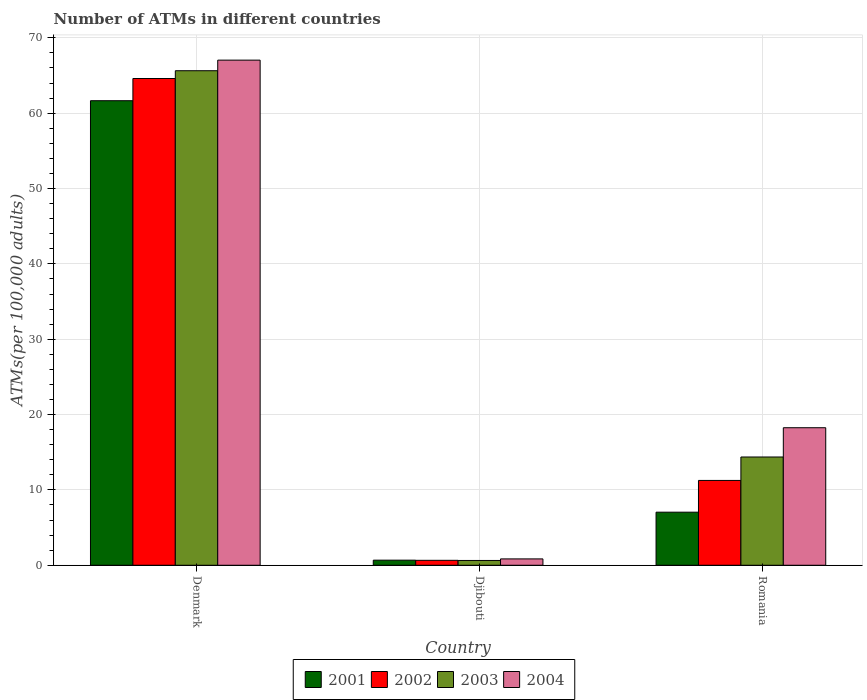How many different coloured bars are there?
Provide a short and direct response. 4. How many groups of bars are there?
Offer a terse response. 3. Are the number of bars per tick equal to the number of legend labels?
Keep it short and to the point. Yes. What is the label of the 3rd group of bars from the left?
Give a very brief answer. Romania. In how many cases, is the number of bars for a given country not equal to the number of legend labels?
Offer a very short reply. 0. What is the number of ATMs in 2003 in Djibouti?
Keep it short and to the point. 0.64. Across all countries, what is the maximum number of ATMs in 2003?
Offer a very short reply. 65.64. Across all countries, what is the minimum number of ATMs in 2003?
Your response must be concise. 0.64. In which country was the number of ATMs in 2001 maximum?
Make the answer very short. Denmark. In which country was the number of ATMs in 2001 minimum?
Make the answer very short. Djibouti. What is the total number of ATMs in 2003 in the graph?
Give a very brief answer. 80.65. What is the difference between the number of ATMs in 2004 in Denmark and that in Djibouti?
Provide a succinct answer. 66.2. What is the difference between the number of ATMs in 2002 in Romania and the number of ATMs in 2001 in Denmark?
Make the answer very short. -50.4. What is the average number of ATMs in 2001 per country?
Provide a succinct answer. 23.13. What is the difference between the number of ATMs of/in 2003 and number of ATMs of/in 2002 in Romania?
Provide a short and direct response. 3.11. What is the ratio of the number of ATMs in 2003 in Denmark to that in Romania?
Provide a short and direct response. 4.57. Is the difference between the number of ATMs in 2003 in Djibouti and Romania greater than the difference between the number of ATMs in 2002 in Djibouti and Romania?
Provide a succinct answer. No. What is the difference between the highest and the second highest number of ATMs in 2001?
Your response must be concise. -60.98. What is the difference between the highest and the lowest number of ATMs in 2003?
Make the answer very short. 65. In how many countries, is the number of ATMs in 2001 greater than the average number of ATMs in 2001 taken over all countries?
Make the answer very short. 1. Is the sum of the number of ATMs in 2004 in Denmark and Romania greater than the maximum number of ATMs in 2001 across all countries?
Your answer should be very brief. Yes. Is it the case that in every country, the sum of the number of ATMs in 2002 and number of ATMs in 2001 is greater than the sum of number of ATMs in 2003 and number of ATMs in 2004?
Offer a terse response. No. What does the 3rd bar from the right in Denmark represents?
Give a very brief answer. 2002. Is it the case that in every country, the sum of the number of ATMs in 2003 and number of ATMs in 2002 is greater than the number of ATMs in 2001?
Make the answer very short. Yes. How many countries are there in the graph?
Your answer should be compact. 3. What is the difference between two consecutive major ticks on the Y-axis?
Your response must be concise. 10. Does the graph contain any zero values?
Provide a short and direct response. No. Where does the legend appear in the graph?
Your response must be concise. Bottom center. How many legend labels are there?
Your response must be concise. 4. What is the title of the graph?
Offer a terse response. Number of ATMs in different countries. What is the label or title of the Y-axis?
Your answer should be very brief. ATMs(per 100,0 adults). What is the ATMs(per 100,000 adults) of 2001 in Denmark?
Make the answer very short. 61.66. What is the ATMs(per 100,000 adults) of 2002 in Denmark?
Offer a very short reply. 64.61. What is the ATMs(per 100,000 adults) in 2003 in Denmark?
Give a very brief answer. 65.64. What is the ATMs(per 100,000 adults) in 2004 in Denmark?
Offer a terse response. 67.04. What is the ATMs(per 100,000 adults) in 2001 in Djibouti?
Offer a very short reply. 0.68. What is the ATMs(per 100,000 adults) in 2002 in Djibouti?
Offer a terse response. 0.66. What is the ATMs(per 100,000 adults) in 2003 in Djibouti?
Your answer should be very brief. 0.64. What is the ATMs(per 100,000 adults) in 2004 in Djibouti?
Provide a succinct answer. 0.84. What is the ATMs(per 100,000 adults) of 2001 in Romania?
Your answer should be compact. 7.04. What is the ATMs(per 100,000 adults) in 2002 in Romania?
Your answer should be compact. 11.26. What is the ATMs(per 100,000 adults) in 2003 in Romania?
Provide a short and direct response. 14.37. What is the ATMs(per 100,000 adults) in 2004 in Romania?
Provide a short and direct response. 18.26. Across all countries, what is the maximum ATMs(per 100,000 adults) in 2001?
Your answer should be very brief. 61.66. Across all countries, what is the maximum ATMs(per 100,000 adults) of 2002?
Make the answer very short. 64.61. Across all countries, what is the maximum ATMs(per 100,000 adults) of 2003?
Your response must be concise. 65.64. Across all countries, what is the maximum ATMs(per 100,000 adults) of 2004?
Keep it short and to the point. 67.04. Across all countries, what is the minimum ATMs(per 100,000 adults) in 2001?
Provide a succinct answer. 0.68. Across all countries, what is the minimum ATMs(per 100,000 adults) in 2002?
Keep it short and to the point. 0.66. Across all countries, what is the minimum ATMs(per 100,000 adults) of 2003?
Your answer should be compact. 0.64. Across all countries, what is the minimum ATMs(per 100,000 adults) in 2004?
Ensure brevity in your answer.  0.84. What is the total ATMs(per 100,000 adults) in 2001 in the graph?
Your answer should be very brief. 69.38. What is the total ATMs(per 100,000 adults) of 2002 in the graph?
Give a very brief answer. 76.52. What is the total ATMs(per 100,000 adults) of 2003 in the graph?
Ensure brevity in your answer.  80.65. What is the total ATMs(per 100,000 adults) in 2004 in the graph?
Your response must be concise. 86.14. What is the difference between the ATMs(per 100,000 adults) of 2001 in Denmark and that in Djibouti?
Your answer should be very brief. 60.98. What is the difference between the ATMs(per 100,000 adults) of 2002 in Denmark and that in Djibouti?
Give a very brief answer. 63.95. What is the difference between the ATMs(per 100,000 adults) in 2003 in Denmark and that in Djibouti?
Offer a very short reply. 65. What is the difference between the ATMs(per 100,000 adults) in 2004 in Denmark and that in Djibouti?
Make the answer very short. 66.2. What is the difference between the ATMs(per 100,000 adults) in 2001 in Denmark and that in Romania?
Your answer should be compact. 54.61. What is the difference between the ATMs(per 100,000 adults) of 2002 in Denmark and that in Romania?
Your response must be concise. 53.35. What is the difference between the ATMs(per 100,000 adults) in 2003 in Denmark and that in Romania?
Provide a succinct answer. 51.27. What is the difference between the ATMs(per 100,000 adults) of 2004 in Denmark and that in Romania?
Give a very brief answer. 48.79. What is the difference between the ATMs(per 100,000 adults) in 2001 in Djibouti and that in Romania?
Your response must be concise. -6.37. What is the difference between the ATMs(per 100,000 adults) in 2002 in Djibouti and that in Romania?
Provide a short and direct response. -10.6. What is the difference between the ATMs(per 100,000 adults) of 2003 in Djibouti and that in Romania?
Provide a succinct answer. -13.73. What is the difference between the ATMs(per 100,000 adults) of 2004 in Djibouti and that in Romania?
Ensure brevity in your answer.  -17.41. What is the difference between the ATMs(per 100,000 adults) in 2001 in Denmark and the ATMs(per 100,000 adults) in 2002 in Djibouti?
Your response must be concise. 61. What is the difference between the ATMs(per 100,000 adults) of 2001 in Denmark and the ATMs(per 100,000 adults) of 2003 in Djibouti?
Provide a short and direct response. 61.02. What is the difference between the ATMs(per 100,000 adults) in 2001 in Denmark and the ATMs(per 100,000 adults) in 2004 in Djibouti?
Your answer should be very brief. 60.81. What is the difference between the ATMs(per 100,000 adults) in 2002 in Denmark and the ATMs(per 100,000 adults) in 2003 in Djibouti?
Offer a very short reply. 63.97. What is the difference between the ATMs(per 100,000 adults) of 2002 in Denmark and the ATMs(per 100,000 adults) of 2004 in Djibouti?
Provide a succinct answer. 63.76. What is the difference between the ATMs(per 100,000 adults) in 2003 in Denmark and the ATMs(per 100,000 adults) in 2004 in Djibouti?
Give a very brief answer. 64.79. What is the difference between the ATMs(per 100,000 adults) of 2001 in Denmark and the ATMs(per 100,000 adults) of 2002 in Romania?
Provide a succinct answer. 50.4. What is the difference between the ATMs(per 100,000 adults) in 2001 in Denmark and the ATMs(per 100,000 adults) in 2003 in Romania?
Your answer should be very brief. 47.29. What is the difference between the ATMs(per 100,000 adults) in 2001 in Denmark and the ATMs(per 100,000 adults) in 2004 in Romania?
Ensure brevity in your answer.  43.4. What is the difference between the ATMs(per 100,000 adults) of 2002 in Denmark and the ATMs(per 100,000 adults) of 2003 in Romania?
Make the answer very short. 50.24. What is the difference between the ATMs(per 100,000 adults) of 2002 in Denmark and the ATMs(per 100,000 adults) of 2004 in Romania?
Your answer should be very brief. 46.35. What is the difference between the ATMs(per 100,000 adults) in 2003 in Denmark and the ATMs(per 100,000 adults) in 2004 in Romania?
Provide a short and direct response. 47.38. What is the difference between the ATMs(per 100,000 adults) in 2001 in Djibouti and the ATMs(per 100,000 adults) in 2002 in Romania?
Make the answer very short. -10.58. What is the difference between the ATMs(per 100,000 adults) in 2001 in Djibouti and the ATMs(per 100,000 adults) in 2003 in Romania?
Your answer should be compact. -13.69. What is the difference between the ATMs(per 100,000 adults) of 2001 in Djibouti and the ATMs(per 100,000 adults) of 2004 in Romania?
Offer a very short reply. -17.58. What is the difference between the ATMs(per 100,000 adults) of 2002 in Djibouti and the ATMs(per 100,000 adults) of 2003 in Romania?
Offer a terse response. -13.71. What is the difference between the ATMs(per 100,000 adults) in 2002 in Djibouti and the ATMs(per 100,000 adults) in 2004 in Romania?
Your response must be concise. -17.6. What is the difference between the ATMs(per 100,000 adults) of 2003 in Djibouti and the ATMs(per 100,000 adults) of 2004 in Romania?
Ensure brevity in your answer.  -17.62. What is the average ATMs(per 100,000 adults) of 2001 per country?
Give a very brief answer. 23.13. What is the average ATMs(per 100,000 adults) of 2002 per country?
Your answer should be compact. 25.51. What is the average ATMs(per 100,000 adults) of 2003 per country?
Make the answer very short. 26.88. What is the average ATMs(per 100,000 adults) in 2004 per country?
Your answer should be very brief. 28.71. What is the difference between the ATMs(per 100,000 adults) of 2001 and ATMs(per 100,000 adults) of 2002 in Denmark?
Your answer should be very brief. -2.95. What is the difference between the ATMs(per 100,000 adults) in 2001 and ATMs(per 100,000 adults) in 2003 in Denmark?
Keep it short and to the point. -3.98. What is the difference between the ATMs(per 100,000 adults) in 2001 and ATMs(per 100,000 adults) in 2004 in Denmark?
Your answer should be compact. -5.39. What is the difference between the ATMs(per 100,000 adults) in 2002 and ATMs(per 100,000 adults) in 2003 in Denmark?
Offer a very short reply. -1.03. What is the difference between the ATMs(per 100,000 adults) of 2002 and ATMs(per 100,000 adults) of 2004 in Denmark?
Make the answer very short. -2.44. What is the difference between the ATMs(per 100,000 adults) in 2003 and ATMs(per 100,000 adults) in 2004 in Denmark?
Your response must be concise. -1.41. What is the difference between the ATMs(per 100,000 adults) in 2001 and ATMs(per 100,000 adults) in 2002 in Djibouti?
Provide a short and direct response. 0.02. What is the difference between the ATMs(per 100,000 adults) of 2001 and ATMs(per 100,000 adults) of 2003 in Djibouti?
Keep it short and to the point. 0.04. What is the difference between the ATMs(per 100,000 adults) of 2001 and ATMs(per 100,000 adults) of 2004 in Djibouti?
Your answer should be very brief. -0.17. What is the difference between the ATMs(per 100,000 adults) of 2002 and ATMs(per 100,000 adults) of 2003 in Djibouti?
Keep it short and to the point. 0.02. What is the difference between the ATMs(per 100,000 adults) in 2002 and ATMs(per 100,000 adults) in 2004 in Djibouti?
Your answer should be compact. -0.19. What is the difference between the ATMs(per 100,000 adults) of 2003 and ATMs(per 100,000 adults) of 2004 in Djibouti?
Provide a succinct answer. -0.21. What is the difference between the ATMs(per 100,000 adults) of 2001 and ATMs(per 100,000 adults) of 2002 in Romania?
Make the answer very short. -4.21. What is the difference between the ATMs(per 100,000 adults) of 2001 and ATMs(per 100,000 adults) of 2003 in Romania?
Your answer should be compact. -7.32. What is the difference between the ATMs(per 100,000 adults) in 2001 and ATMs(per 100,000 adults) in 2004 in Romania?
Give a very brief answer. -11.21. What is the difference between the ATMs(per 100,000 adults) in 2002 and ATMs(per 100,000 adults) in 2003 in Romania?
Provide a short and direct response. -3.11. What is the difference between the ATMs(per 100,000 adults) of 2002 and ATMs(per 100,000 adults) of 2004 in Romania?
Provide a succinct answer. -7. What is the difference between the ATMs(per 100,000 adults) in 2003 and ATMs(per 100,000 adults) in 2004 in Romania?
Your answer should be very brief. -3.89. What is the ratio of the ATMs(per 100,000 adults) of 2001 in Denmark to that in Djibouti?
Give a very brief answer. 91.18. What is the ratio of the ATMs(per 100,000 adults) in 2002 in Denmark to that in Djibouti?
Give a very brief answer. 98.45. What is the ratio of the ATMs(per 100,000 adults) of 2003 in Denmark to that in Djibouti?
Keep it short and to the point. 102.88. What is the ratio of the ATMs(per 100,000 adults) of 2004 in Denmark to that in Djibouti?
Offer a very short reply. 79.46. What is the ratio of the ATMs(per 100,000 adults) in 2001 in Denmark to that in Romania?
Your answer should be very brief. 8.75. What is the ratio of the ATMs(per 100,000 adults) of 2002 in Denmark to that in Romania?
Give a very brief answer. 5.74. What is the ratio of the ATMs(per 100,000 adults) of 2003 in Denmark to that in Romania?
Offer a terse response. 4.57. What is the ratio of the ATMs(per 100,000 adults) of 2004 in Denmark to that in Romania?
Provide a short and direct response. 3.67. What is the ratio of the ATMs(per 100,000 adults) in 2001 in Djibouti to that in Romania?
Ensure brevity in your answer.  0.1. What is the ratio of the ATMs(per 100,000 adults) in 2002 in Djibouti to that in Romania?
Keep it short and to the point. 0.06. What is the ratio of the ATMs(per 100,000 adults) of 2003 in Djibouti to that in Romania?
Make the answer very short. 0.04. What is the ratio of the ATMs(per 100,000 adults) in 2004 in Djibouti to that in Romania?
Keep it short and to the point. 0.05. What is the difference between the highest and the second highest ATMs(per 100,000 adults) of 2001?
Keep it short and to the point. 54.61. What is the difference between the highest and the second highest ATMs(per 100,000 adults) of 2002?
Ensure brevity in your answer.  53.35. What is the difference between the highest and the second highest ATMs(per 100,000 adults) in 2003?
Provide a succinct answer. 51.27. What is the difference between the highest and the second highest ATMs(per 100,000 adults) in 2004?
Offer a very short reply. 48.79. What is the difference between the highest and the lowest ATMs(per 100,000 adults) of 2001?
Offer a terse response. 60.98. What is the difference between the highest and the lowest ATMs(per 100,000 adults) in 2002?
Provide a short and direct response. 63.95. What is the difference between the highest and the lowest ATMs(per 100,000 adults) of 2003?
Provide a short and direct response. 65. What is the difference between the highest and the lowest ATMs(per 100,000 adults) of 2004?
Provide a succinct answer. 66.2. 